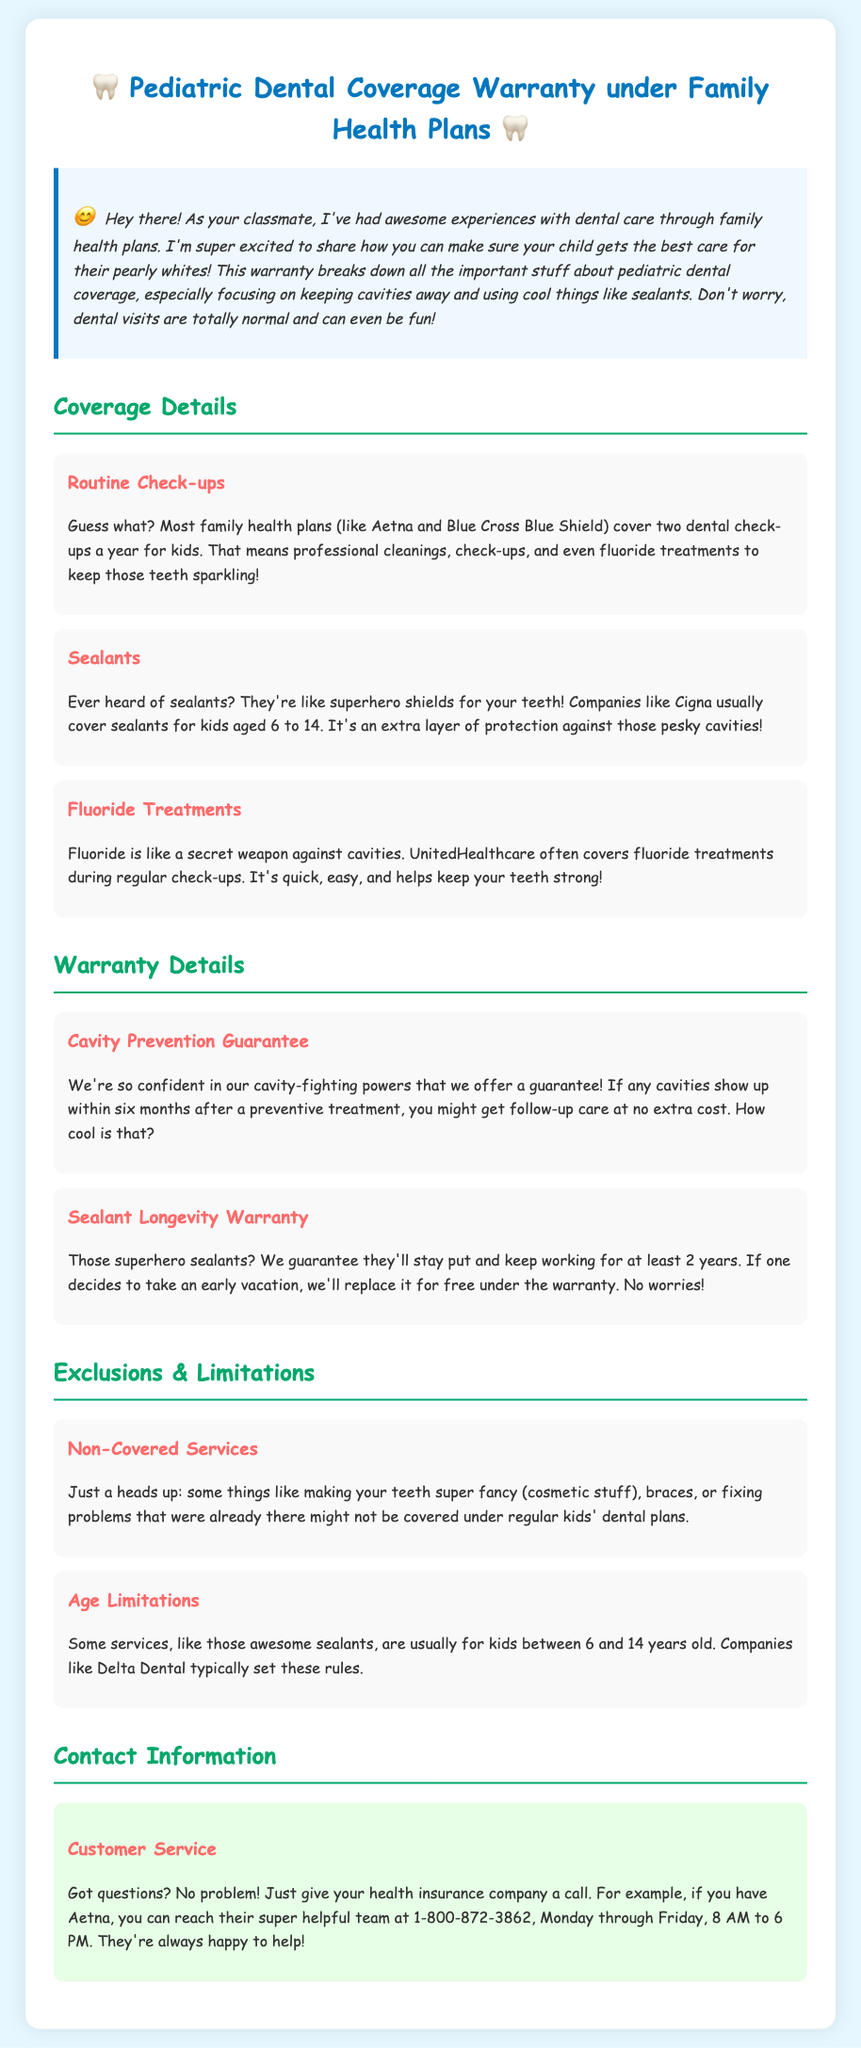What is covered under routine check-ups? The document states that routine check-ups usually cover professional cleanings, check-ups, and fluoride treatments.
Answer: Professional cleanings, check-ups, and fluoride treatments How many dental check-ups are covered per year for kids? The document specifies that most family health plans cover two dental check-ups a year for kids.
Answer: Two What age range are sealants typically covered? The warranty mentions that sealants are usually covered for kids aged 6 to 14.
Answer: 6 to 14 What is the warranty period for sealants? The document states that sealants are guaranteed to stay for at least 2 years.
Answer: 2 years What happens if a cavity appears within six months after preventive treatment? According to the warranty, follow-up care might be provided at no extra cost if a cavity shows up within this time frame.
Answer: Follow-up care at no extra cost Which companies are mentioned for routine check-ups and sealants? The document mentions Aetna and Blue Cross Blue Shield for routine check-ups and Cigna for sealants.
Answer: Aetna and Blue Cross Blue Shield; Cigna What is one example of a non-covered service? The document indicates that cosmetic dentistry (making teeth fancy) is an example of a non-covered service.
Answer: Cosmetic services Who should you contact for questions about the warranty? The document states that you should contact your health insurance company for questions.
Answer: Health insurance company 